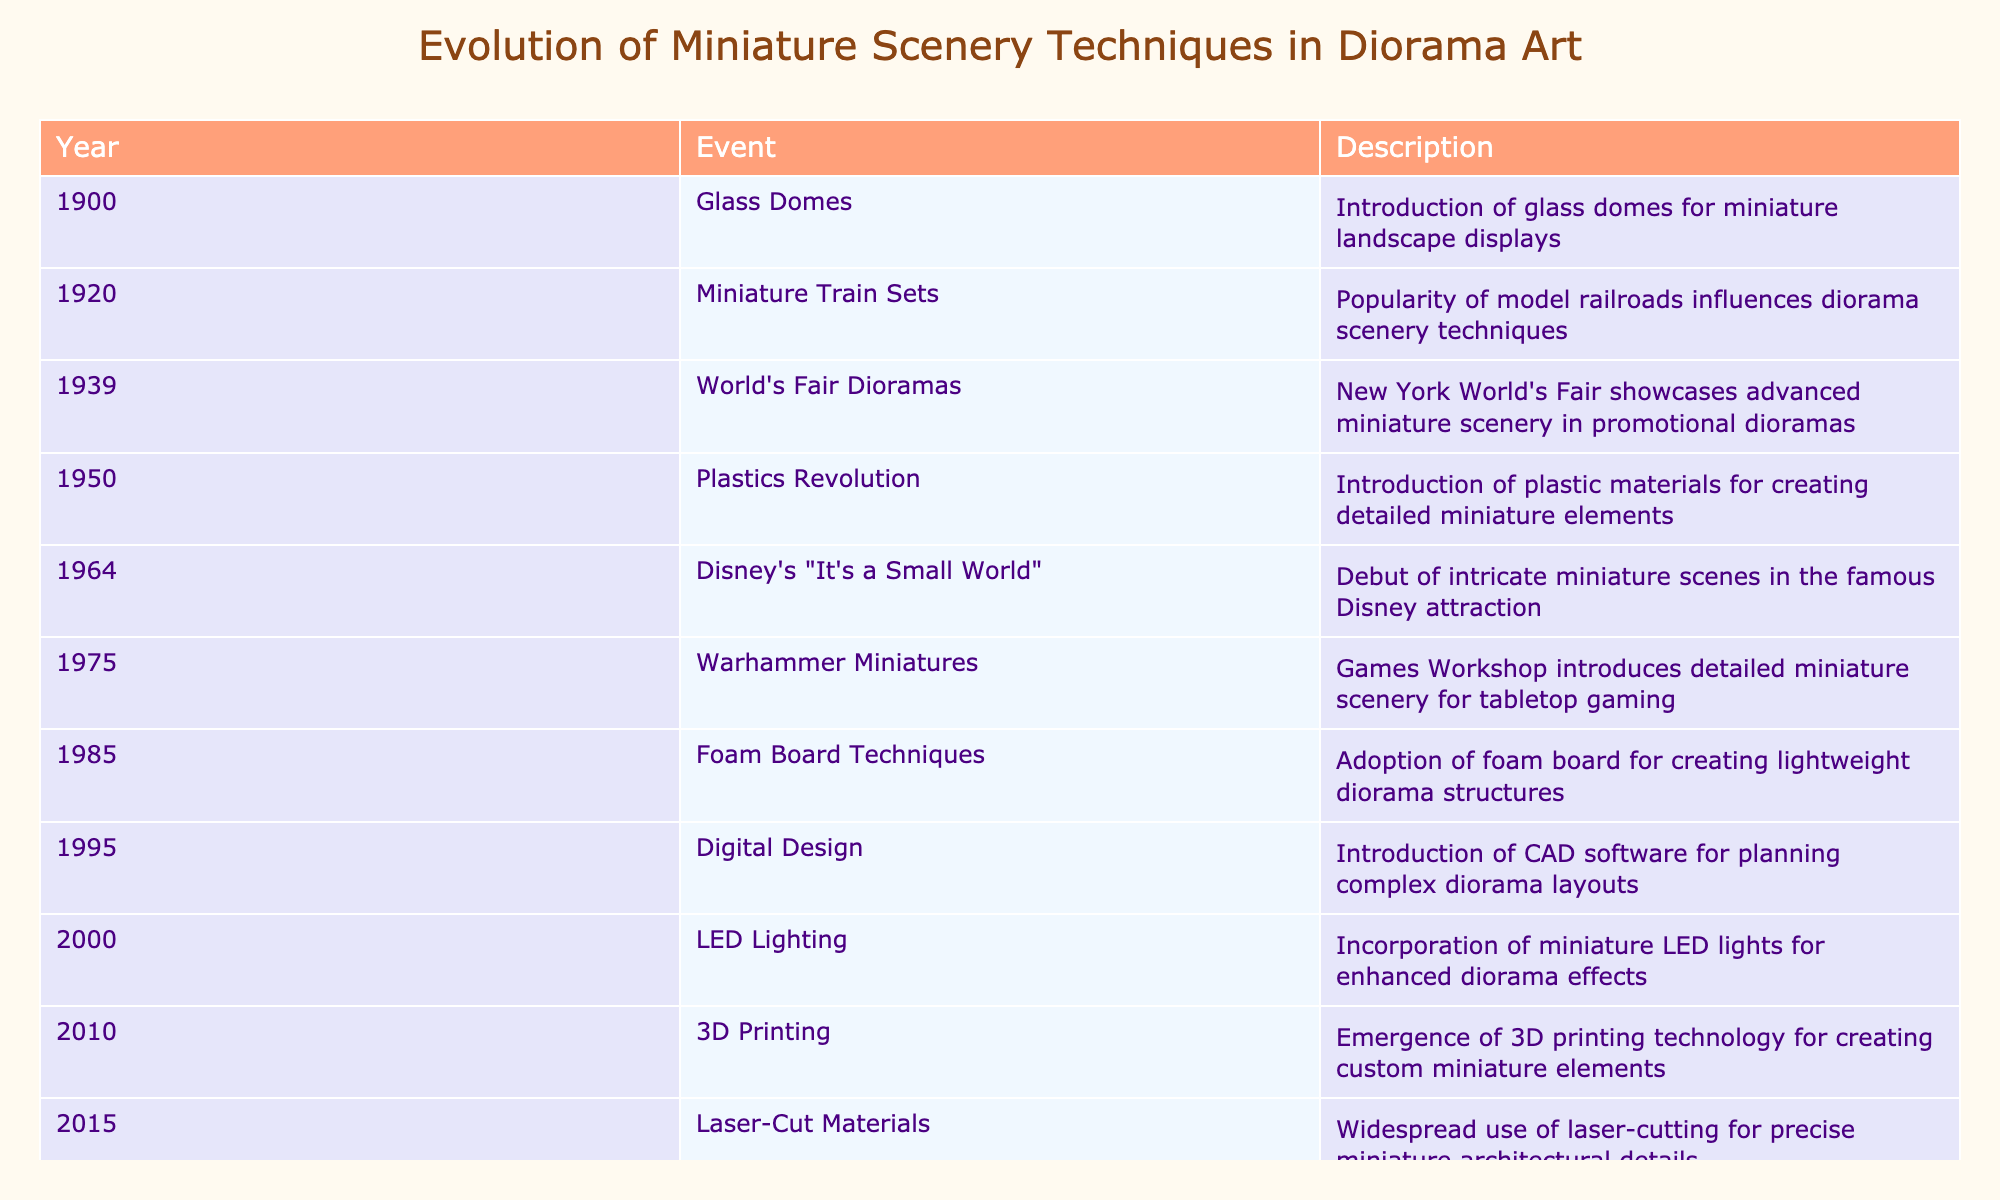What significant event in the evolution of miniature scenery techniques occurred in 1950? According to the table, the significant event in 1950 was the Plastics Revolution, which introduced plastic materials for creating detailed miniature elements.
Answer: Plastics Revolution Which event in 1975 contributed to the techniques for creating diorama scenery? The table indicates that in 1975, Warhammer Miniatures were introduced by Games Workshop, which contributed detailed miniature scenery for tabletop gaming.
Answer: Warhammer Miniatures What year did the introduction of LED lighting in dioramas occur? The table states that the incorporation of miniature LED lights for enhanced diorama effects occurred in the year 2000.
Answer: 2000 Based on the table, did the integration of augmented reality technology happen before 2020? By examining the table, we see that the integration of augmented reality technology occurred in 2020, hence it did not happen before this year.
Answer: No What is the average year of the events listed from 1900 to 2015? The table lists events from 1900 to 2015. To find the average, we sum the years (1900 + 1920 + 1939 + 1950 + 1964 + 1975 + 1985 + 1995 + 2000 + 2010 + 2015 = 22108) and divide by the number of events (11). This gives us an average year of 2010.73, which rounds to 2011.
Answer: 2011 How many events introduced new materials or technologies after 1975? Reviewing the table, the relevant events after 1975 are Foam Board Techniques (1985), Digital Design (1995), LED Lighting (2000), 3D Printing (2010), and Laser-Cut Materials (2015). This totals five events that introduced new materials or technologies.
Answer: 5 Was there an introduction of a new technique in diorama art around 2010? The table shows that in 2010, 3D Printing emerged as a new technology for creating custom miniature elements, thus the answer is yes.
Answer: Yes Which event marks the earliest introduction of diorama techniques in this timeline? The earliest event listed in the table is the Glass Domes introduction in 1900, marking the beginning of miniature landscape displays.
Answer: Glass Domes How many years apart were the events of 1964 and 1975? By examining the years 1964 and 1975, we calculate the difference as 1975 - 1964 = 11 years.
Answer: 11 years 